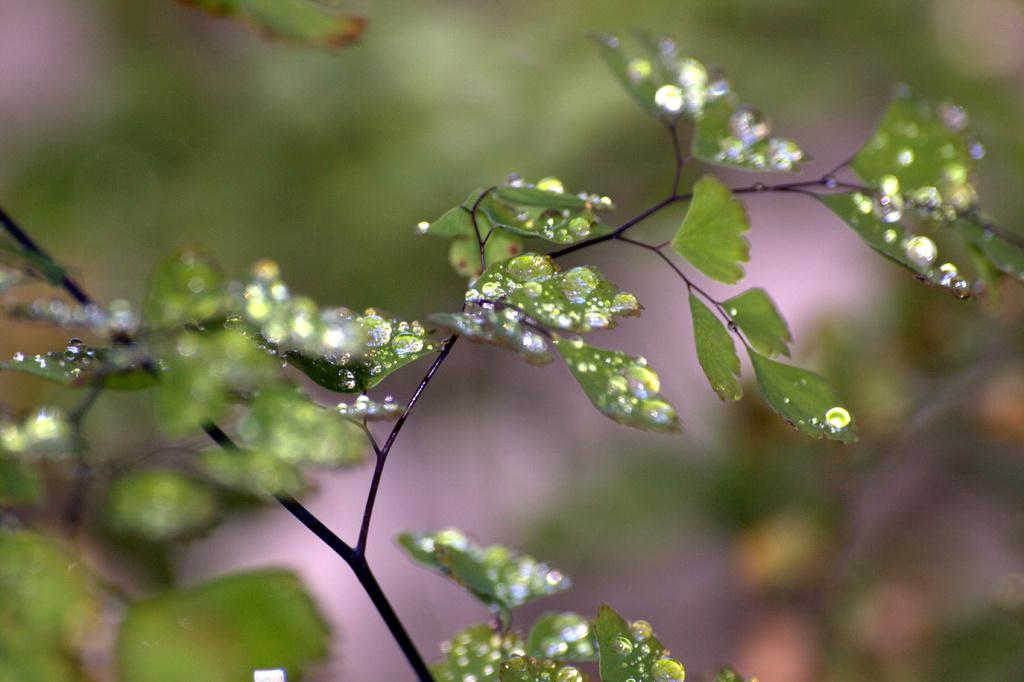What celestial bodies are depicted in the image? There are planets in the image. What is covering the surface of the planets? Water droplets are present on the planets. What type of coat is being worn by the ducks in the image? There are no ducks present in the image, and therefore no coats can be observed. 